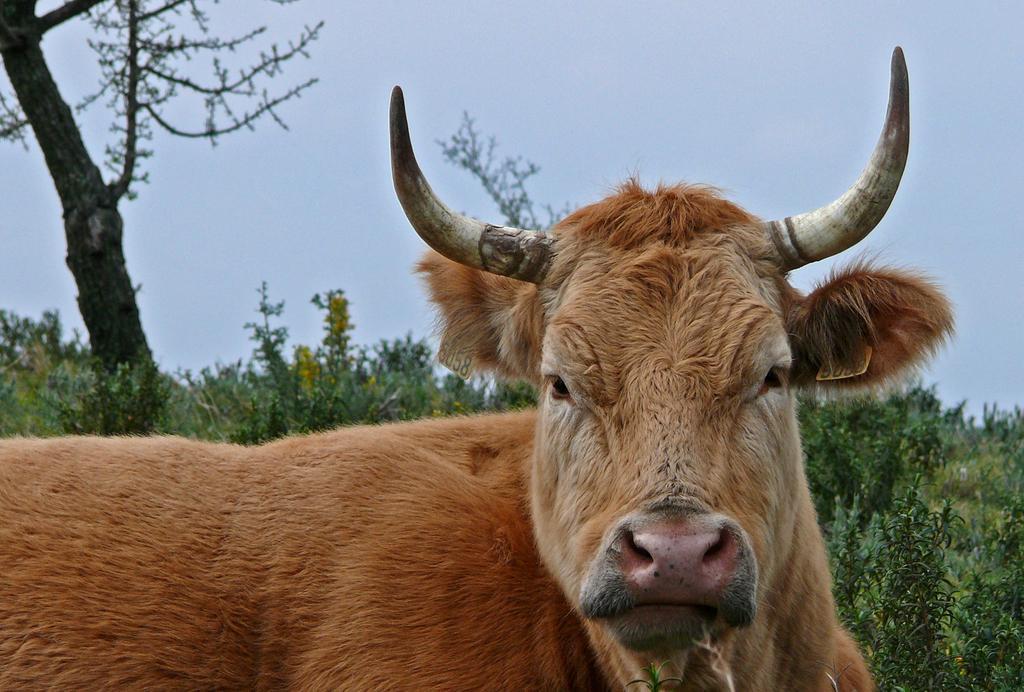Can you describe this image briefly? In this image I can see a brown colour bull over here. I can also see few tags and on these tags I can see few numbers are written. In the background I can see few trees and the sky. 